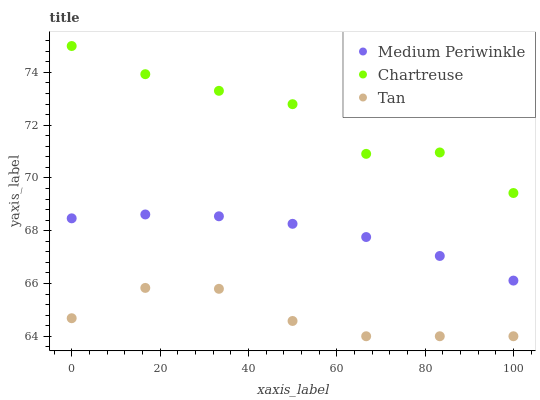Does Tan have the minimum area under the curve?
Answer yes or no. Yes. Does Chartreuse have the maximum area under the curve?
Answer yes or no. Yes. Does Medium Periwinkle have the minimum area under the curve?
Answer yes or no. No. Does Medium Periwinkle have the maximum area under the curve?
Answer yes or no. No. Is Medium Periwinkle the smoothest?
Answer yes or no. Yes. Is Chartreuse the roughest?
Answer yes or no. Yes. Is Tan the smoothest?
Answer yes or no. No. Is Tan the roughest?
Answer yes or no. No. Does Tan have the lowest value?
Answer yes or no. Yes. Does Medium Periwinkle have the lowest value?
Answer yes or no. No. Does Chartreuse have the highest value?
Answer yes or no. Yes. Does Medium Periwinkle have the highest value?
Answer yes or no. No. Is Medium Periwinkle less than Chartreuse?
Answer yes or no. Yes. Is Medium Periwinkle greater than Tan?
Answer yes or no. Yes. Does Medium Periwinkle intersect Chartreuse?
Answer yes or no. No. 